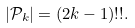<formula> <loc_0><loc_0><loc_500><loc_500>| \mathcal { P } _ { k } | & = ( 2 k - 1 ) ! ! .</formula> 